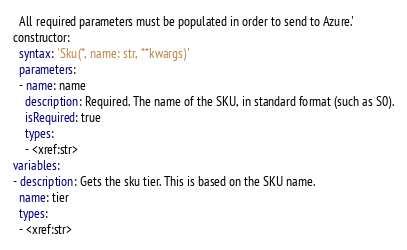Convert code to text. <code><loc_0><loc_0><loc_500><loc_500><_YAML_>

  All required parameters must be populated in order to send to Azure.'
constructor:
  syntax: 'Sku(*, name: str, **kwargs)'
  parameters:
  - name: name
    description: Required. The name of the SKU, in standard format (such as S0).
    isRequired: true
    types:
    - <xref:str>
variables:
- description: Gets the sku tier. This is based on the SKU name.
  name: tier
  types:
  - <xref:str>
</code> 